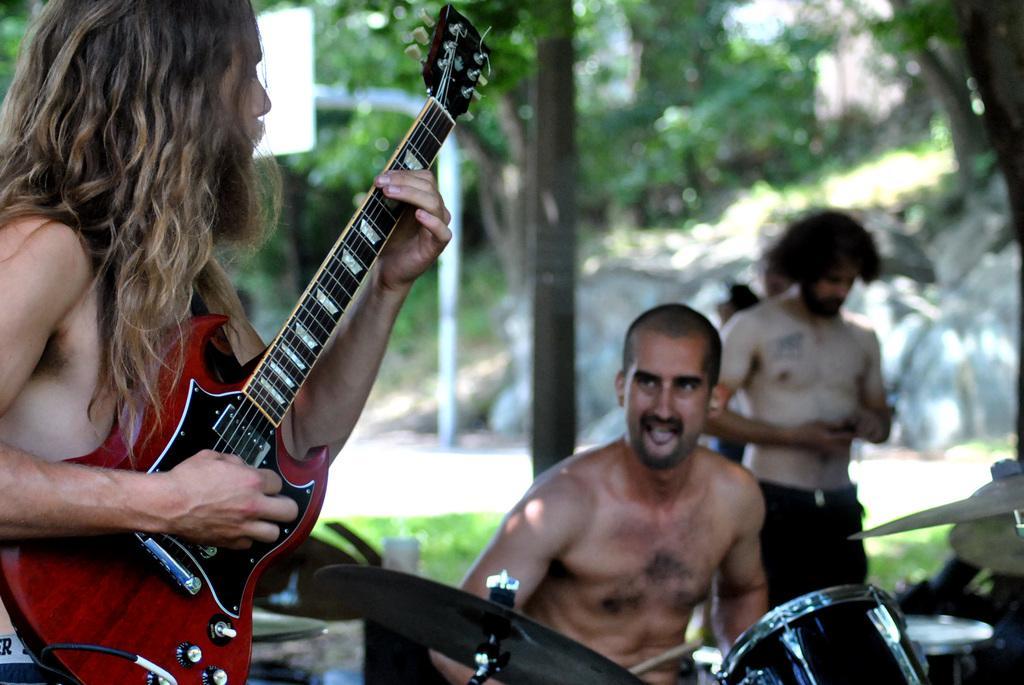In one or two sentences, can you explain what this image depicts? In the picture there are three people one person is sitting and two of them are standing the sitting person is playing drums the person who is standing is playing guitar in the background there are trees, poles and a road. 